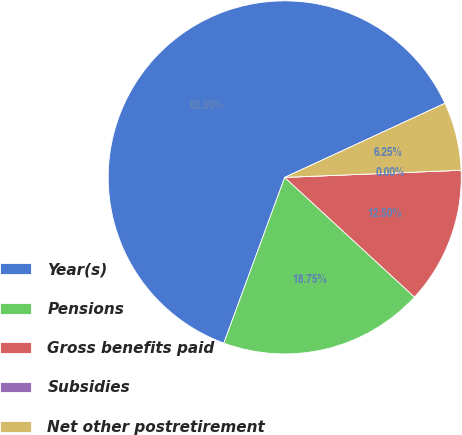<chart> <loc_0><loc_0><loc_500><loc_500><pie_chart><fcel>Year(s)<fcel>Pensions<fcel>Gross benefits paid<fcel>Subsidies<fcel>Net other postretirement<nl><fcel>62.5%<fcel>18.75%<fcel>12.5%<fcel>0.0%<fcel>6.25%<nl></chart> 